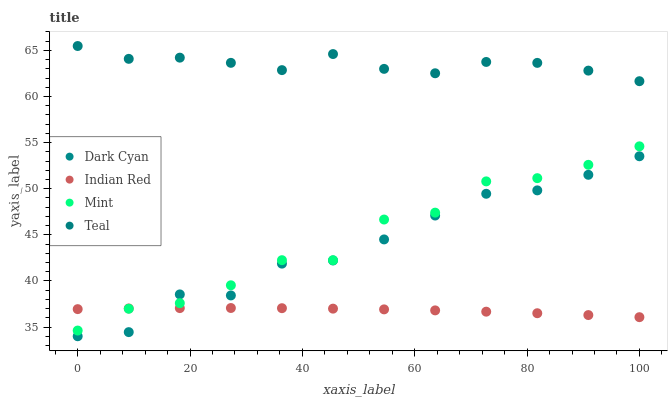Does Indian Red have the minimum area under the curve?
Answer yes or no. Yes. Does Teal have the maximum area under the curve?
Answer yes or no. Yes. Does Mint have the minimum area under the curve?
Answer yes or no. No. Does Mint have the maximum area under the curve?
Answer yes or no. No. Is Indian Red the smoothest?
Answer yes or no. Yes. Is Mint the roughest?
Answer yes or no. Yes. Is Teal the smoothest?
Answer yes or no. No. Is Teal the roughest?
Answer yes or no. No. Does Dark Cyan have the lowest value?
Answer yes or no. Yes. Does Mint have the lowest value?
Answer yes or no. No. Does Teal have the highest value?
Answer yes or no. Yes. Does Mint have the highest value?
Answer yes or no. No. Is Mint less than Teal?
Answer yes or no. Yes. Is Teal greater than Mint?
Answer yes or no. Yes. Does Dark Cyan intersect Indian Red?
Answer yes or no. Yes. Is Dark Cyan less than Indian Red?
Answer yes or no. No. Is Dark Cyan greater than Indian Red?
Answer yes or no. No. Does Mint intersect Teal?
Answer yes or no. No. 